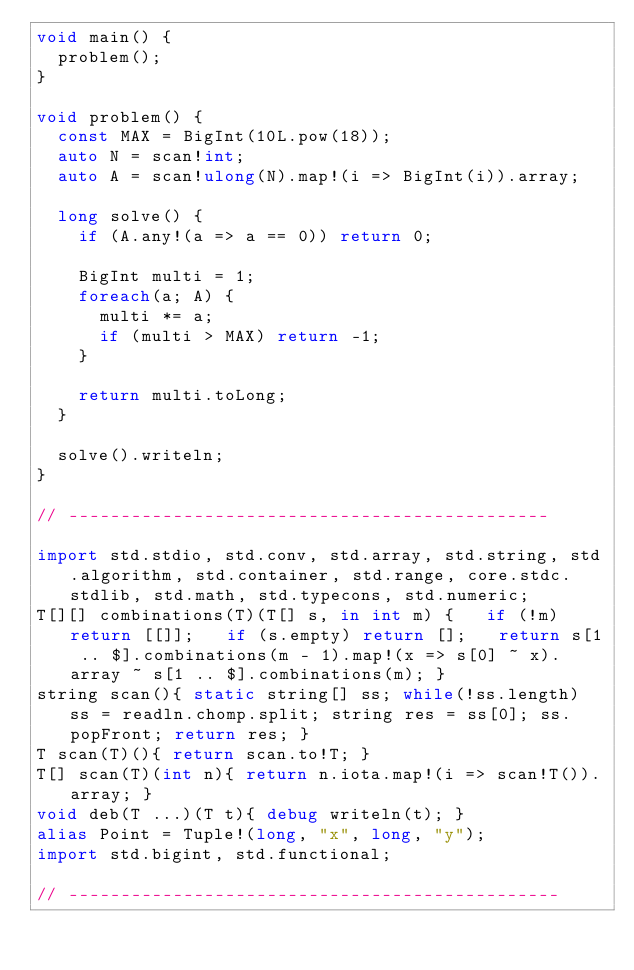Convert code to text. <code><loc_0><loc_0><loc_500><loc_500><_D_>void main() {
  problem();
}

void problem() {
  const MAX = BigInt(10L.pow(18));
  auto N = scan!int;
  auto A = scan!ulong(N).map!(i => BigInt(i)).array;

  long solve() {
    if (A.any!(a => a == 0)) return 0;
    
    BigInt multi = 1;
    foreach(a; A) {
      multi *= a;
      if (multi > MAX) return -1;
    }

    return multi.toLong;
  }

  solve().writeln;
}

// ----------------------------------------------

import std.stdio, std.conv, std.array, std.string, std.algorithm, std.container, std.range, core.stdc.stdlib, std.math, std.typecons, std.numeric;
T[][] combinations(T)(T[] s, in int m) {   if (!m) return [[]];   if (s.empty) return [];   return s[1 .. $].combinations(m - 1).map!(x => s[0] ~ x).array ~ s[1 .. $].combinations(m); }
string scan(){ static string[] ss; while(!ss.length) ss = readln.chomp.split; string res = ss[0]; ss.popFront; return res; }
T scan(T)(){ return scan.to!T; }
T[] scan(T)(int n){ return n.iota.map!(i => scan!T()).array; }
void deb(T ...)(T t){ debug writeln(t); }
alias Point = Tuple!(long, "x", long, "y");
import std.bigint, std.functional;

// -----------------------------------------------
</code> 